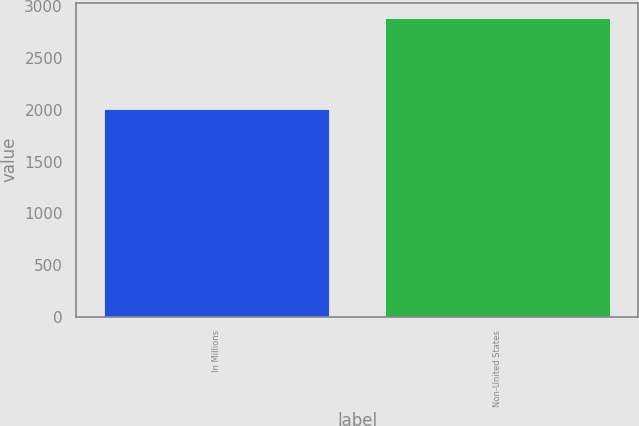Convert chart to OTSL. <chart><loc_0><loc_0><loc_500><loc_500><bar_chart><fcel>In Millions<fcel>Non-United States<nl><fcel>2011<fcel>2892.4<nl></chart> 